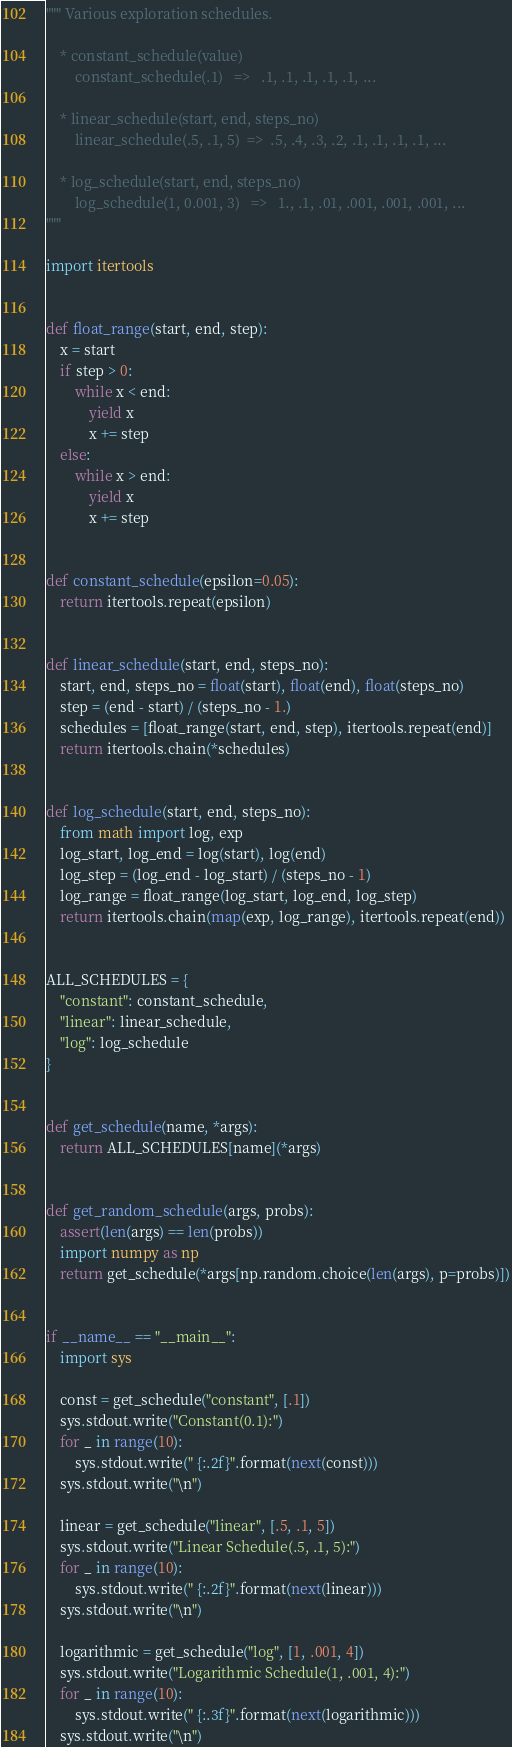Convert code to text. <code><loc_0><loc_0><loc_500><loc_500><_Python_>""" Various exploration schedules.

    * constant_schedule(value)
        constant_schedule(.1)   =>   .1, .1, .1, .1, .1, ...

    * linear_schedule(start, end, steps_no)
        linear_schedule(.5, .1, 5)  =>  .5, .4, .3, .2, .1, .1, .1, .1, ...

    * log_schedule(start, end, steps_no)
        log_schedule(1, 0.001, 3)   =>   1., .1, .01, .001, .001, .001, ...
"""

import itertools


def float_range(start, end, step):
    x = start
    if step > 0:
        while x < end:
            yield x
            x += step
    else:
        while x > end:
            yield x
            x += step


def constant_schedule(epsilon=0.05):
    return itertools.repeat(epsilon)


def linear_schedule(start, end, steps_no):
    start, end, steps_no = float(start), float(end), float(steps_no)
    step = (end - start) / (steps_no - 1.)
    schedules = [float_range(start, end, step), itertools.repeat(end)]
    return itertools.chain(*schedules)


def log_schedule(start, end, steps_no):
    from math import log, exp
    log_start, log_end = log(start), log(end)
    log_step = (log_end - log_start) / (steps_no - 1)
    log_range = float_range(log_start, log_end, log_step)
    return itertools.chain(map(exp, log_range), itertools.repeat(end))


ALL_SCHEDULES = {
    "constant": constant_schedule,
    "linear": linear_schedule,
    "log": log_schedule
}


def get_schedule(name, *args):
    return ALL_SCHEDULES[name](*args)


def get_random_schedule(args, probs):
    assert(len(args) == len(probs))
    import numpy as np
    return get_schedule(*args[np.random.choice(len(args), p=probs)])


if __name__ == "__main__":
    import sys

    const = get_schedule("constant", [.1])
    sys.stdout.write("Constant(0.1):")
    for _ in range(10):
        sys.stdout.write(" {:.2f}".format(next(const)))
    sys.stdout.write("\n")

    linear = get_schedule("linear", [.5, .1, 5])
    sys.stdout.write("Linear Schedule(.5, .1, 5):")
    for _ in range(10):
        sys.stdout.write(" {:.2f}".format(next(linear)))
    sys.stdout.write("\n")

    logarithmic = get_schedule("log", [1, .001, 4])
    sys.stdout.write("Logarithmic Schedule(1, .001, 4):")
    for _ in range(10):
        sys.stdout.write(" {:.3f}".format(next(logarithmic)))
    sys.stdout.write("\n")
</code> 